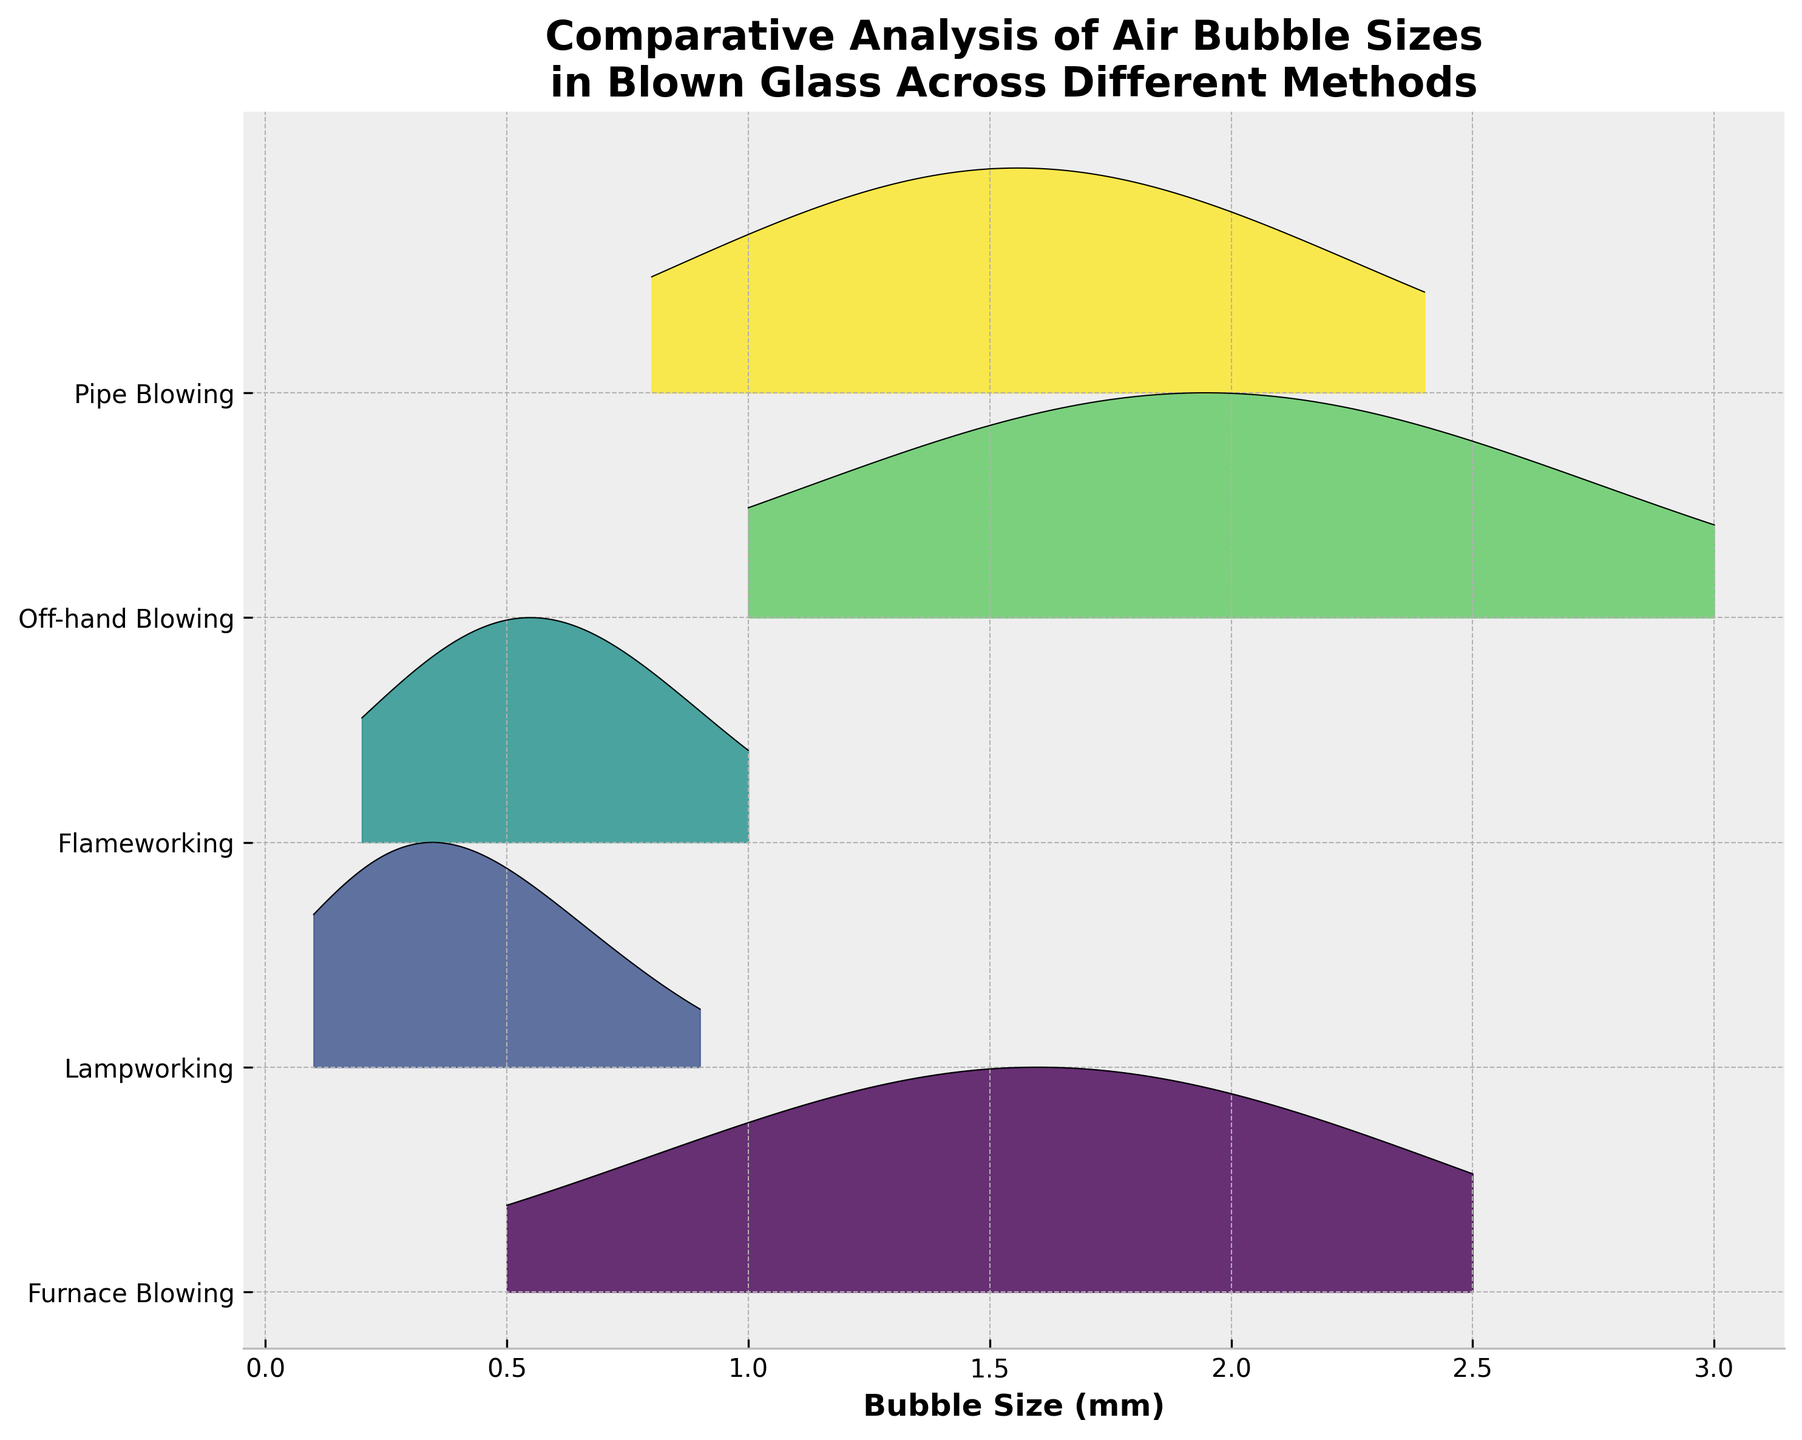Which glassblowing method has the largest average bubble size? By examining where the peak of the KDE curves lies, Pipe Blowing’s peak occurs around a higher bubble size value compared to other methods.
Answer: Pipe Blowing What are the bubble size ranges used in Lampworking? Look at the KDE curve for Lampworking; it stretches from 0.1 to 0.9 mm on the x-axis.
Answer: 0.1 to 0.9 mm Which method shows the broadest range of bubble sizes? Check which KDE curve spans the widest range on the x-axis; Off-hand Blowing covers from 1.0 to 3.0 mm.
Answer: Off-hand Blowing Which two methods have bubble sizes that overlap around the 2.0 mm mark? Observe where the KDE curves intersect around the 2.0 mm bubble size; Furnace Blowing and Pipe Blowing both have curves peaking around 2.0 mm.
Answer: Furnace Blowing and Pipe Blowing Which method has the highest frequency of bubbles with the smallest size? Identify which KDE curve has a peak near the smallest bubble size; Lampworking has the highest peak closest to 0.1 mm.
Answer: Lampworking Do any methods have a peak frequency at the exact same bubble size? Compare the peaks of the KDE curves to see if any align on the x-axis; No two KDE curves peak at the exact same bubble size.
Answer: No What is the difference in bubble sizes between the peaks of Furnace Blowing and Flameworking? Note the peak of the KDE curves for each method; Furnace Blowing peaks at 1.5 mm and Flameworking peaks at 0.6 mm, so the difference is 1.5 - 0.6 = 0.9 mm.
Answer: 0.9 mm How does the spread of bubble sizes in Pipe Blowing compare to Furnace Blowing? Compare the width of the KDE curves; Pipe Blowing has a broader distribution (0.8 to 2.4 mm) than Furnace Blowing (0.5 to 2.5 mm).
Answer: Broader Which glassblowing method has the sharpest peak indicating the most consistency in bubble sizes? Observe the height and narrowness of the KDE curves; Lampworking has the sharpest and tallest peak around 0.3 mm.
Answer: Lampworking What is the range of bubble sizes covered by the KDE curve of Pipe Blowing? Look at the start and end points of the KDE curve for Pipe Blowing; it ranges from 0.8 to 2.4 mm.
Answer: 0.8 to 2.4 mm 